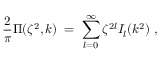Convert formula to latex. <formula><loc_0><loc_0><loc_500><loc_500>{ \frac { 2 } { \pi } } \Pi ( \zeta ^ { 2 } , k ) \, = \, \sum _ { l = 0 } ^ { \infty } \zeta ^ { 2 l } I _ { l } ( k ^ { 2 } ) \, ,</formula> 